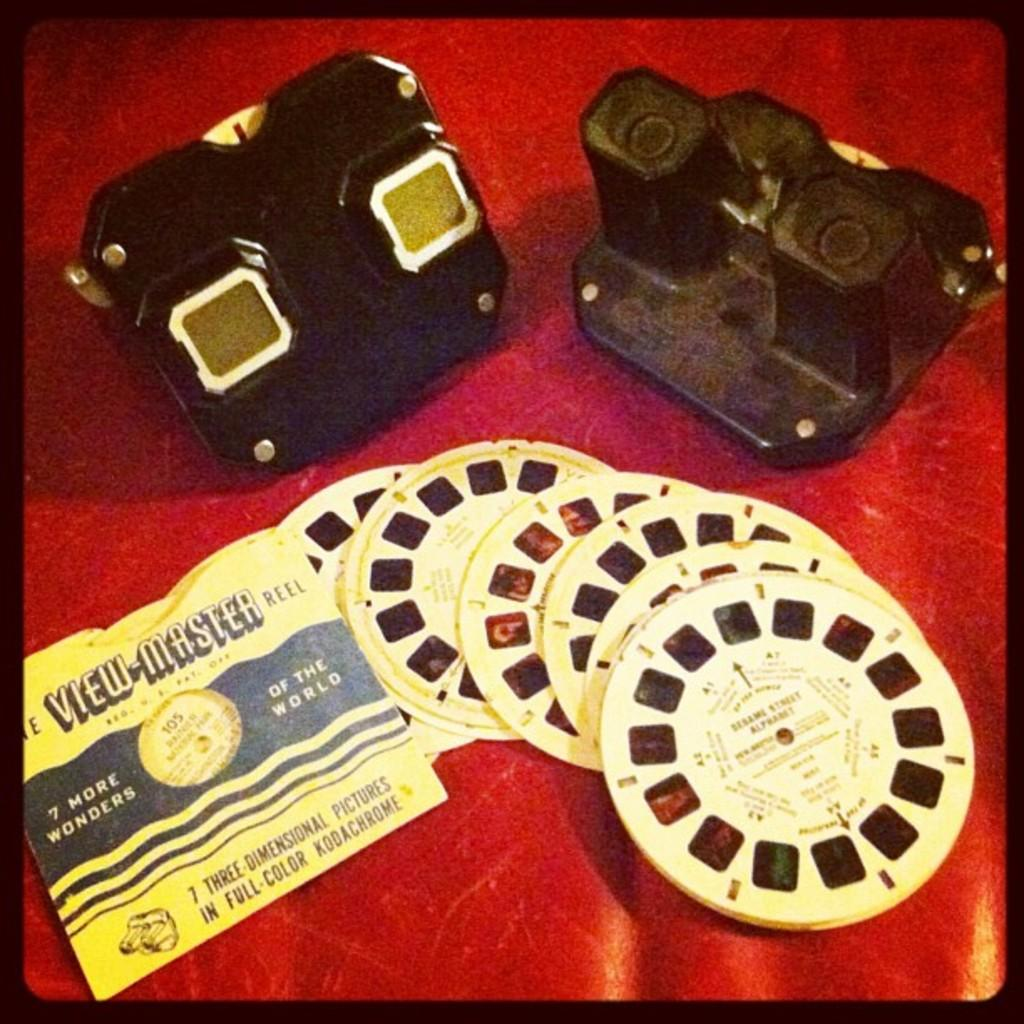What type of objects are at the bottom of the image? There are camera reels in yellow color at the bottom of the image. What can be seen on the left side of the image? There is a black object on the left side of the image. How do the ants interact with the camera reels in the image? There are no ants present in the image, so they cannot interact with the camera reels. What type of vehicle is parked next to the black object in the image? There is no vehicle present in the image, so it cannot be determined if a van or any other type of vehicle is parked next to the black object. 